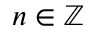<formula> <loc_0><loc_0><loc_500><loc_500>n \in \mathbb { Z }</formula> 